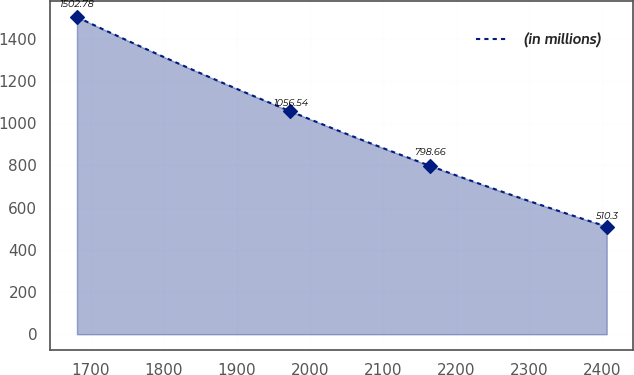Convert chart. <chart><loc_0><loc_0><loc_500><loc_500><line_chart><ecel><fcel>(in millions)<nl><fcel>1681.21<fcel>1502.78<nl><fcel>1973.34<fcel>1056.54<nl><fcel>2164.21<fcel>798.66<nl><fcel>2406.5<fcel>510.3<nl></chart> 